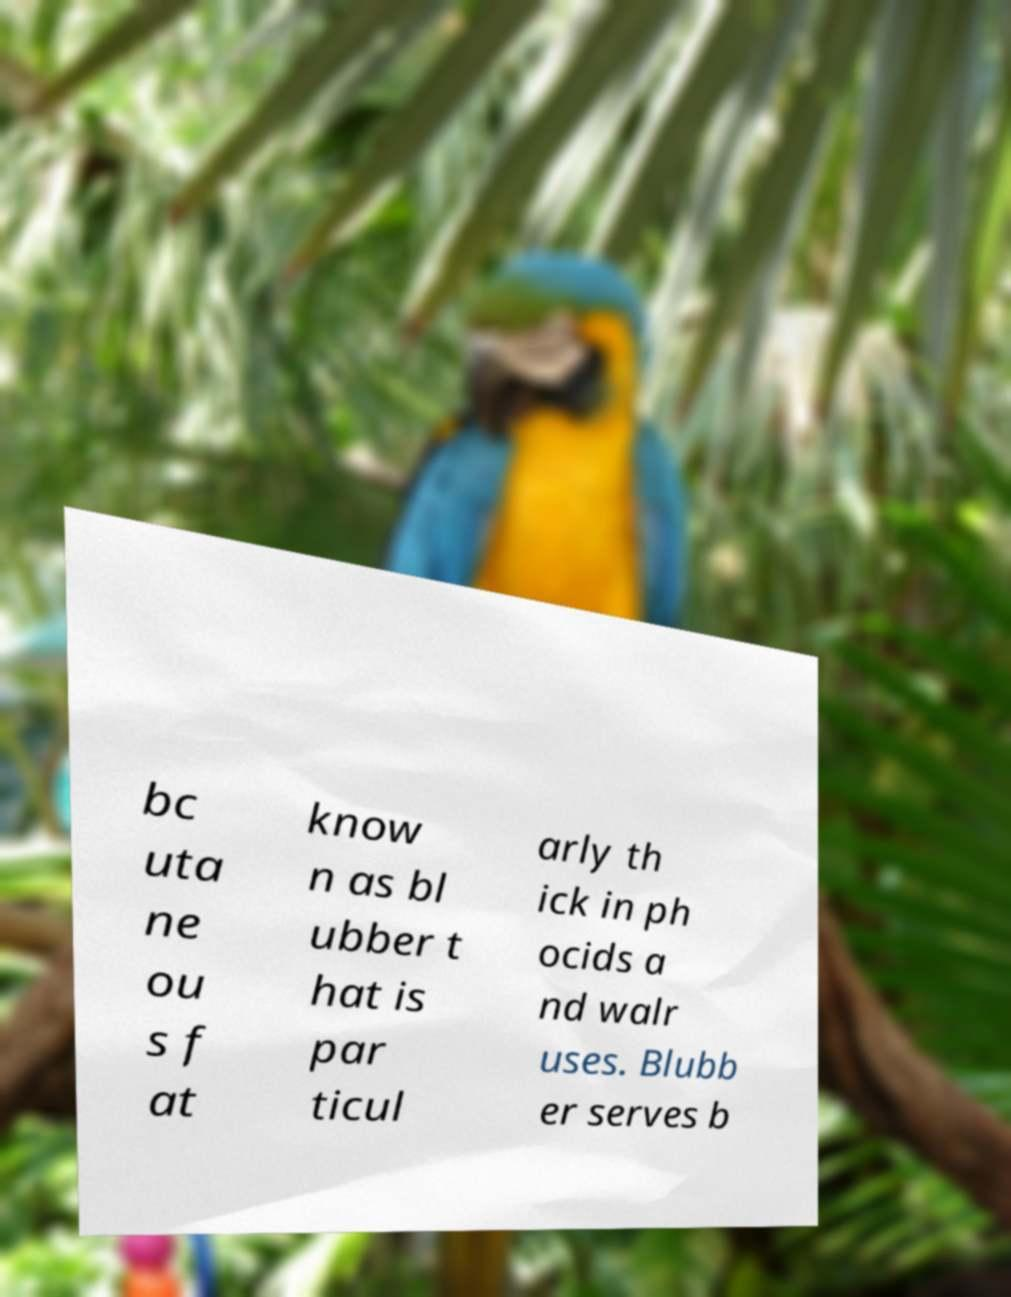For documentation purposes, I need the text within this image transcribed. Could you provide that? bc uta ne ou s f at know n as bl ubber t hat is par ticul arly th ick in ph ocids a nd walr uses. Blubb er serves b 